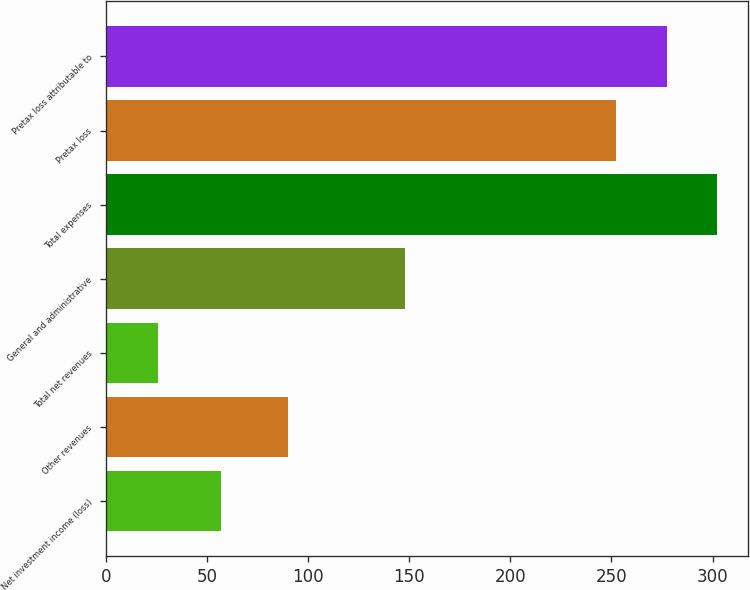Convert chart. <chart><loc_0><loc_0><loc_500><loc_500><bar_chart><fcel>Net investment income (loss)<fcel>Other revenues<fcel>Total net revenues<fcel>General and administrative<fcel>Total expenses<fcel>Pretax loss<fcel>Pretax loss attributable to<nl><fcel>57<fcel>90<fcel>26<fcel>148<fcel>302.4<fcel>252<fcel>277.2<nl></chart> 